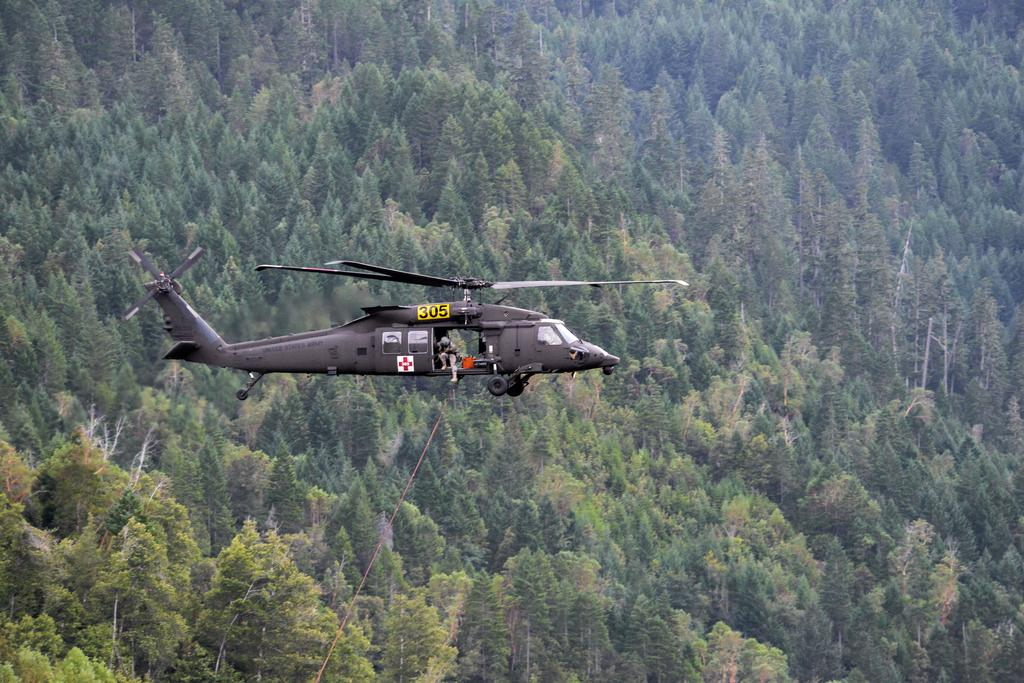What is the main subject of the image? The main subject of the image is a helicopter. What is the helicopter doing in the image? The helicopter is flying in the air. What else can be seen in the image besides the helicopter? There are trees visible in the image. What type of shame can be seen on the helicopter's face in the image? There is no face or expression on the helicopter in the image, as it is a machine and not capable of experiencing emotions like shame. 